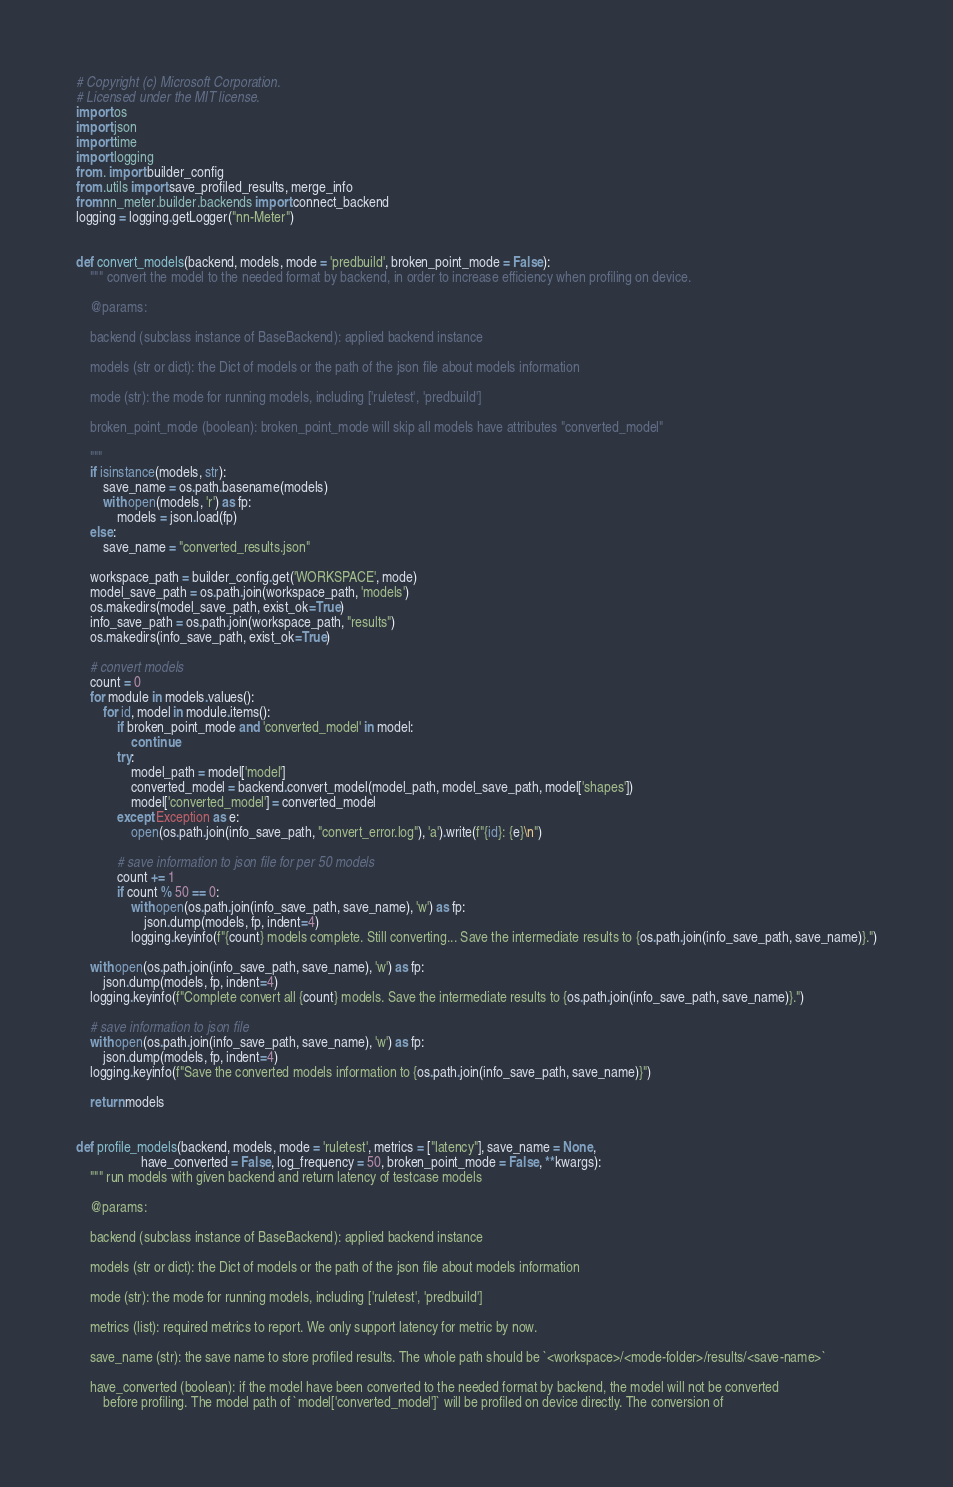Convert code to text. <code><loc_0><loc_0><loc_500><loc_500><_Python_># Copyright (c) Microsoft Corporation.
# Licensed under the MIT license.
import os
import json
import time
import logging
from . import builder_config
from .utils import save_profiled_results, merge_info
from nn_meter.builder.backends import connect_backend
logging = logging.getLogger("nn-Meter")


def convert_models(backend, models, mode = 'predbuild', broken_point_mode = False):
    """ convert the model to the needed format by backend, in order to increase efficiency when profiling on device.

    @params:

    backend (subclass instance of BaseBackend): applied backend instance

    models (str or dict): the Dict of models or the path of the json file about models information 

    mode (str): the mode for running models, including ['ruletest', 'predbuild']

    broken_point_mode (boolean): broken_point_mode will skip all models have attributes "converted_model"

    """
    if isinstance(models, str):
        save_name = os.path.basename(models)
        with open(models, 'r') as fp:
            models = json.load(fp)
    else:
        save_name = "converted_results.json"

    workspace_path = builder_config.get('WORKSPACE', mode)
    model_save_path = os.path.join(workspace_path, 'models')
    os.makedirs(model_save_path, exist_ok=True)
    info_save_path = os.path.join(workspace_path, "results")
    os.makedirs(info_save_path, exist_ok=True)

    # convert models
    count = 0
    for module in models.values():
        for id, model in module.items():
            if broken_point_mode and 'converted_model' in model:
                continue
            try:
                model_path = model['model']
                converted_model = backend.convert_model(model_path, model_save_path, model['shapes'])
                model['converted_model'] = converted_model
            except Exception as e:
                open(os.path.join(info_save_path, "convert_error.log"), 'a').write(f"{id}: {e}\n")

            # save information to json file for per 50 models
            count += 1
            if count % 50 == 0:
                with open(os.path.join(info_save_path, save_name), 'w') as fp:
                    json.dump(models, fp, indent=4)
                logging.keyinfo(f"{count} models complete. Still converting... Save the intermediate results to {os.path.join(info_save_path, save_name)}.")

    with open(os.path.join(info_save_path, save_name), 'w') as fp:
        json.dump(models, fp, indent=4)
    logging.keyinfo(f"Complete convert all {count} models. Save the intermediate results to {os.path.join(info_save_path, save_name)}.")

    # save information to json file
    with open(os.path.join(info_save_path, save_name), 'w') as fp:
        json.dump(models, fp, indent=4)
    logging.keyinfo(f"Save the converted models information to {os.path.join(info_save_path, save_name)}")
    
    return models


def profile_models(backend, models, mode = 'ruletest', metrics = ["latency"], save_name = None,
                   have_converted = False, log_frequency = 50, broken_point_mode = False, **kwargs):
    """ run models with given backend and return latency of testcase models

    @params:

    backend (subclass instance of BaseBackend): applied backend instance

    models (str or dict): the Dict of models or the path of the json file about models information 

    mode (str): the mode for running models, including ['ruletest', 'predbuild']

    metrics (list): required metrics to report. We only support latency for metric by now.

    save_name (str): the save name to store profiled results. The whole path should be `<workspace>/<mode-folder>/results/<save-name>`

    have_converted (boolean): if the model have been converted to the needed format by backend, the model will not be converted
        before profiling. The model path of `model['converted_model']` will be profiled on device directly. The conversion of</code> 